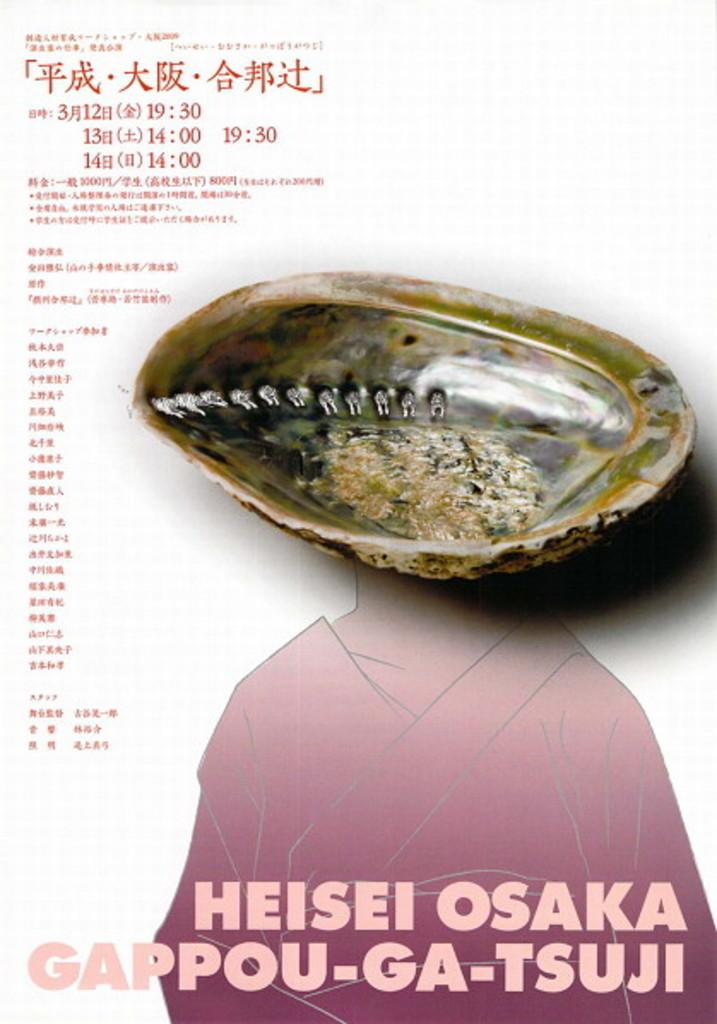What is featured on the poster in the image? There is a poster in the image, and it contains a shell. What else can be seen on the poster besides the shell? There is text on the poster. What type of creature can be seen interacting with the shell on the poster? There is no creature shown interacting with the shell on the poster; only the shell and text are present. What behavior is exhibited by the shell on the poster? The shell is an inanimate object and does not exhibit any behavior. 